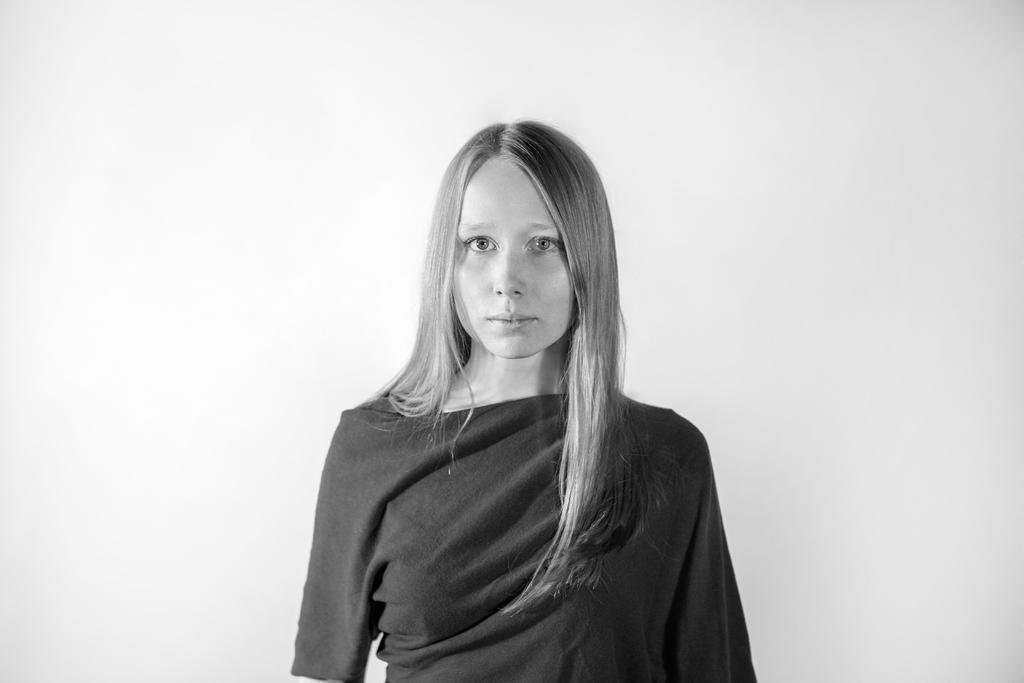Who is present in the image? There is a woman in the image. What is the color of the background in the image? The background of the image is white in color. How is the image presented in terms of color? The image is in black and white mode. What type of hat is the woman wearing in the image? There is no hat visible in the image, as it is in black and white mode. Can you tell me how much toothpaste the woman is holding in the image? There is no toothpaste present in the image. 